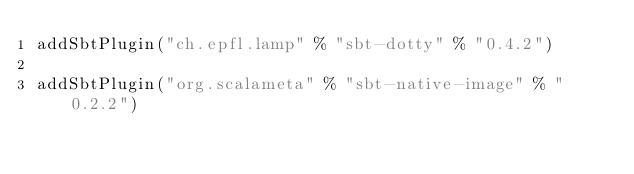Convert code to text. <code><loc_0><loc_0><loc_500><loc_500><_Scala_>addSbtPlugin("ch.epfl.lamp" % "sbt-dotty" % "0.4.2")

addSbtPlugin("org.scalameta" % "sbt-native-image" % "0.2.2")
</code> 